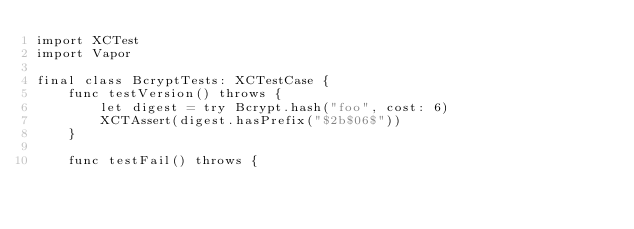<code> <loc_0><loc_0><loc_500><loc_500><_Swift_>import XCTest
import Vapor

final class BcryptTests: XCTestCase {
    func testVersion() throws {
        let digest = try Bcrypt.hash("foo", cost: 6)
        XCTAssert(digest.hasPrefix("$2b$06$"))
    }

    func testFail() throws {</code> 